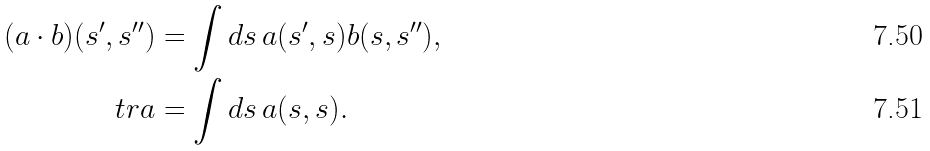Convert formula to latex. <formula><loc_0><loc_0><loc_500><loc_500>( a \cdot b ) ( s ^ { \prime } , s ^ { \prime \prime } ) & = \int d s \, a ( s ^ { \prime } , s ) b ( s , s ^ { \prime \prime } ) , \\ \ t r a & = \int d s \, a ( s , s ) .</formula> 